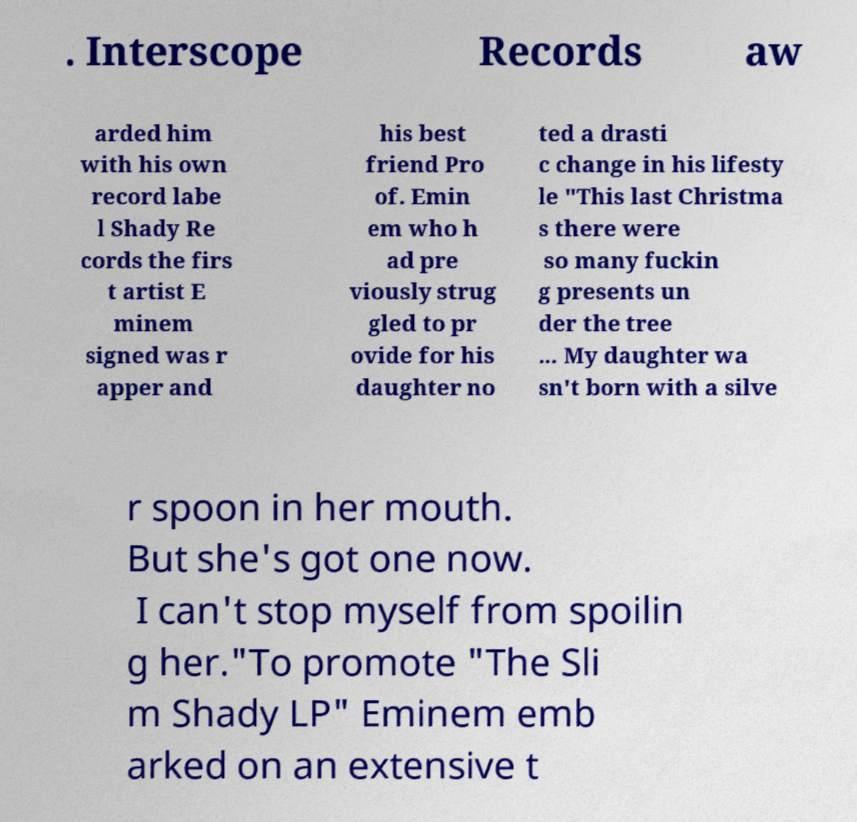Could you assist in decoding the text presented in this image and type it out clearly? . Interscope Records aw arded him with his own record labe l Shady Re cords the firs t artist E minem signed was r apper and his best friend Pro of. Emin em who h ad pre viously strug gled to pr ovide for his daughter no ted a drasti c change in his lifesty le "This last Christma s there were so many fuckin g presents un der the tree ... My daughter wa sn't born with a silve r spoon in her mouth. But she's got one now. I can't stop myself from spoilin g her."To promote "The Sli m Shady LP" Eminem emb arked on an extensive t 